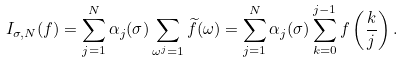Convert formula to latex. <formula><loc_0><loc_0><loc_500><loc_500>I _ { \sigma , N } ( f ) = \sum _ { j = 1 } ^ { N } \alpha _ { j } ( \sigma ) \sum _ { \omega ^ { j } = 1 } \widetilde { f } ( \omega ) = \sum _ { j = 1 } ^ { N } \alpha _ { j } ( \sigma ) \sum _ { k = 0 } ^ { j - 1 } f \left ( \frac { k } { j } \right ) .</formula> 